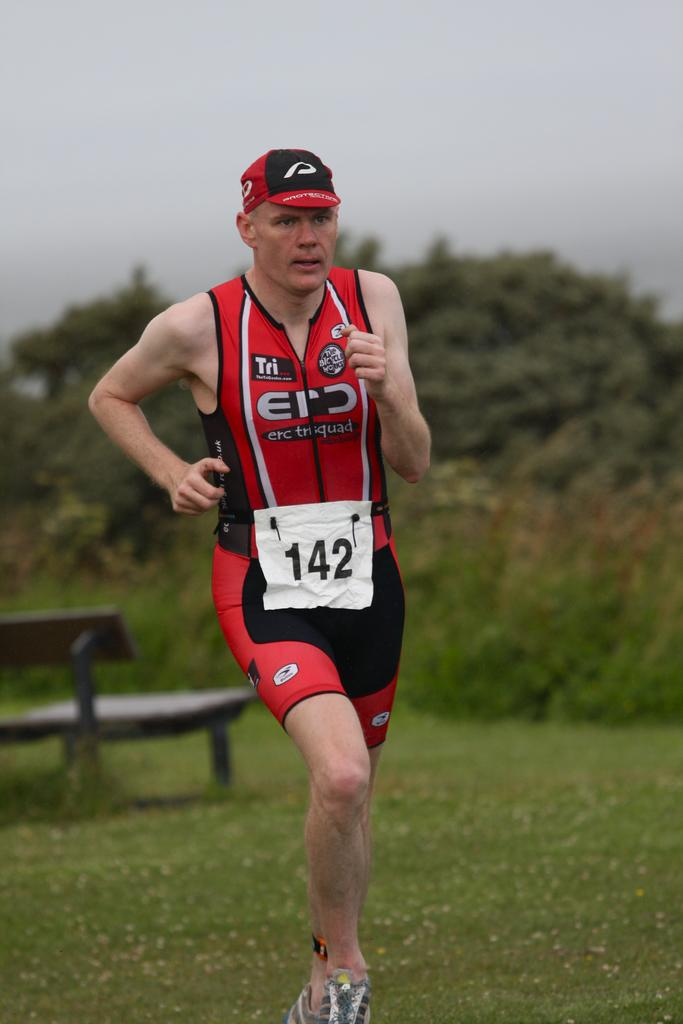<image>
Give a short and clear explanation of the subsequent image. Runner number 142 is wearing red and black as he runs. 